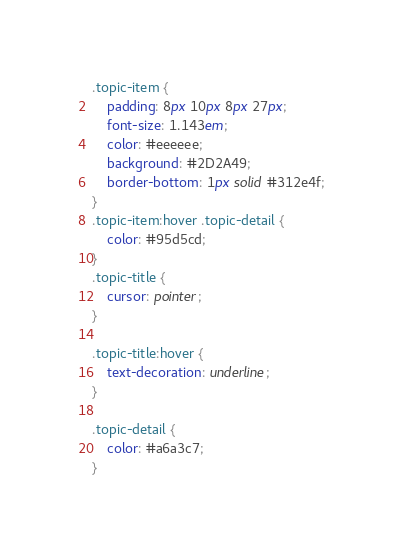<code> <loc_0><loc_0><loc_500><loc_500><_CSS_>.topic-item {
    padding: 8px 10px 8px 27px;
    font-size: 1.143em;
    color: #eeeeee;
    background: #2D2A49;
    border-bottom: 1px solid #312e4f;
}
.topic-item:hover .topic-detail {
    color: #95d5cd;
}
.topic-title {
    cursor: pointer;
}

.topic-title:hover {
    text-decoration: underline;
}

.topic-detail {
    color: #a6a3c7;
}</code> 